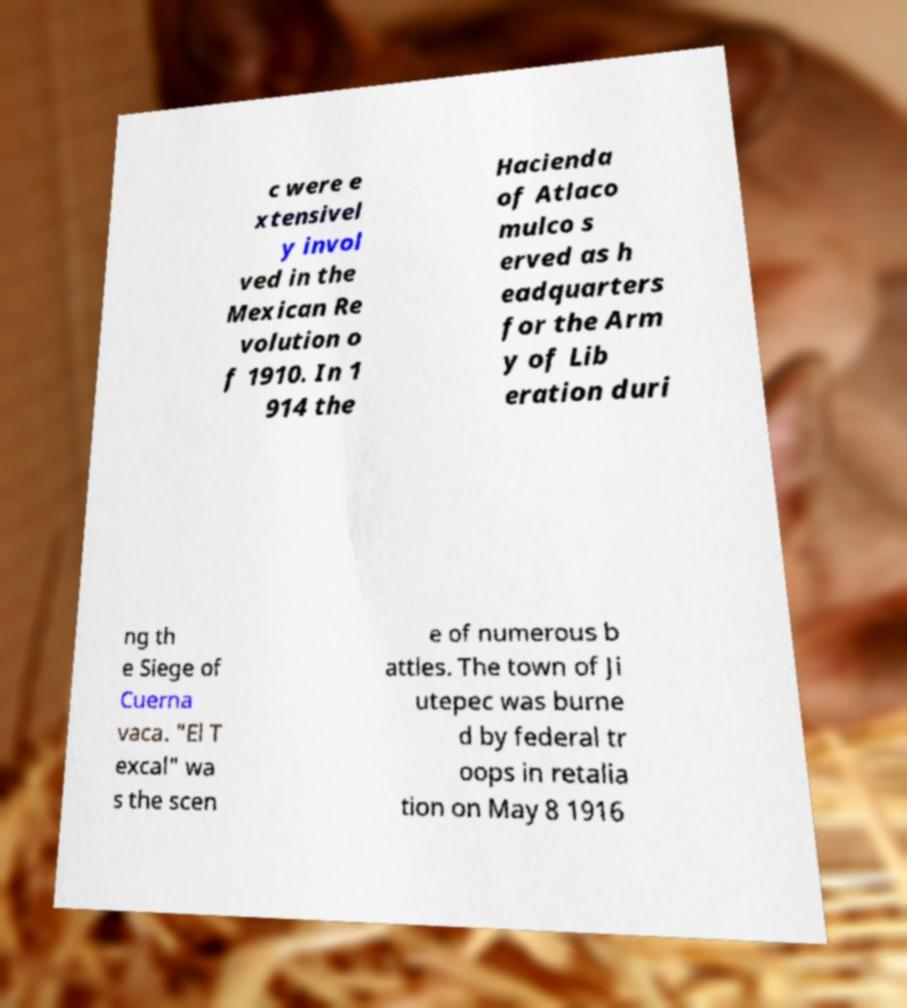Please identify and transcribe the text found in this image. c were e xtensivel y invol ved in the Mexican Re volution o f 1910. In 1 914 the Hacienda of Atlaco mulco s erved as h eadquarters for the Arm y of Lib eration duri ng th e Siege of Cuerna vaca. "El T excal" wa s the scen e of numerous b attles. The town of Ji utepec was burne d by federal tr oops in retalia tion on May 8 1916 